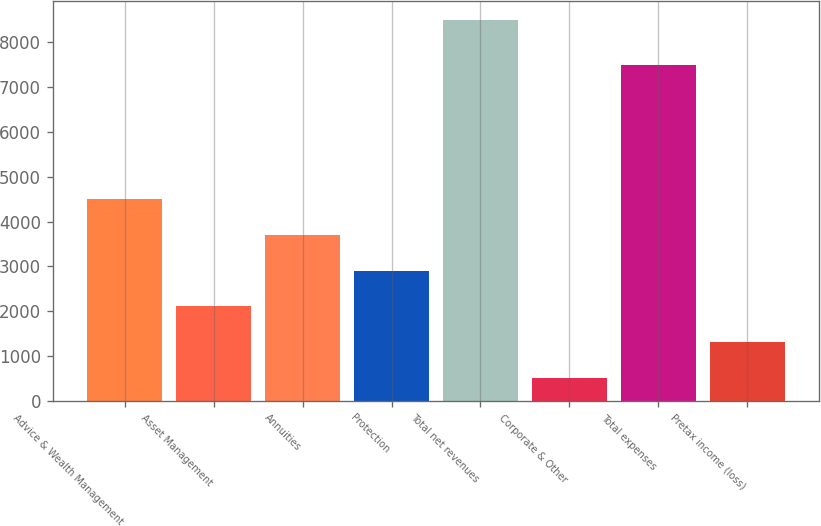<chart> <loc_0><loc_0><loc_500><loc_500><bar_chart><fcel>Advice & Wealth Management<fcel>Asset Management<fcel>Annuities<fcel>Protection<fcel>Total net revenues<fcel>Corporate & Other<fcel>Total expenses<fcel>Pretax income (loss)<nl><fcel>4507<fcel>2107.6<fcel>3707.2<fcel>2907.4<fcel>8506<fcel>508<fcel>7498<fcel>1307.8<nl></chart> 